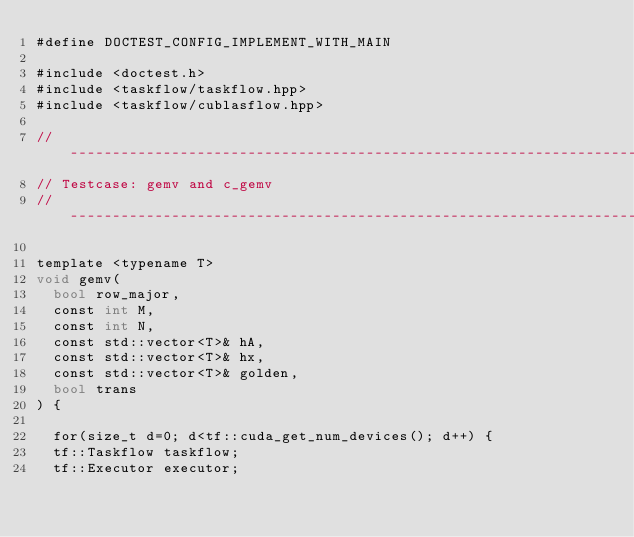<code> <loc_0><loc_0><loc_500><loc_500><_Cuda_>#define DOCTEST_CONFIG_IMPLEMENT_WITH_MAIN

#include <doctest.h>
#include <taskflow/taskflow.hpp>
#include <taskflow/cublasflow.hpp>

// ----------------------------------------------------------------------------
// Testcase: gemv and c_gemv
// ----------------------------------------------------------------------------

template <typename T>
void gemv(
  bool row_major,
  const int M, 
  const int N, 
  const std::vector<T>& hA,
  const std::vector<T>& hx,
  const std::vector<T>& golden,
  bool trans
) {

  for(size_t d=0; d<tf::cuda_get_num_devices(); d++) {
  tf::Taskflow taskflow;
  tf::Executor executor;
</code> 